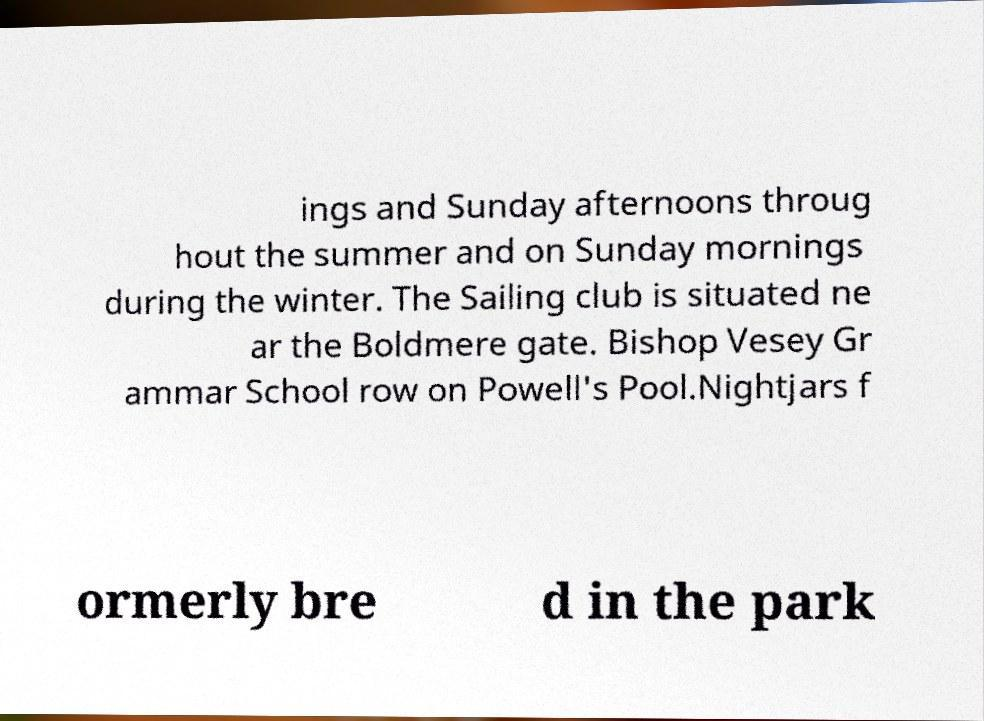Please identify and transcribe the text found in this image. ings and Sunday afternoons throug hout the summer and on Sunday mornings during the winter. The Sailing club is situated ne ar the Boldmere gate. Bishop Vesey Gr ammar School row on Powell's Pool.Nightjars f ormerly bre d in the park 